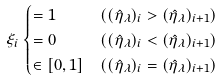Convert formula to latex. <formula><loc_0><loc_0><loc_500><loc_500>\xi _ { i } & \begin{cases} = 1 & ( ( \hat { \eta } _ { \lambda } ) _ { i } > ( \hat { \eta } _ { \lambda } ) _ { i + 1 } ) \\ = 0 & ( ( \hat { \eta } _ { \lambda } ) _ { i } < ( \hat { \eta } _ { \lambda } ) _ { i + 1 } ) \\ \in [ 0 , 1 ] & ( ( \hat { \eta } _ { \lambda } ) _ { i } = ( \hat { \eta } _ { \lambda } ) _ { i + 1 } ) \end{cases}</formula> 